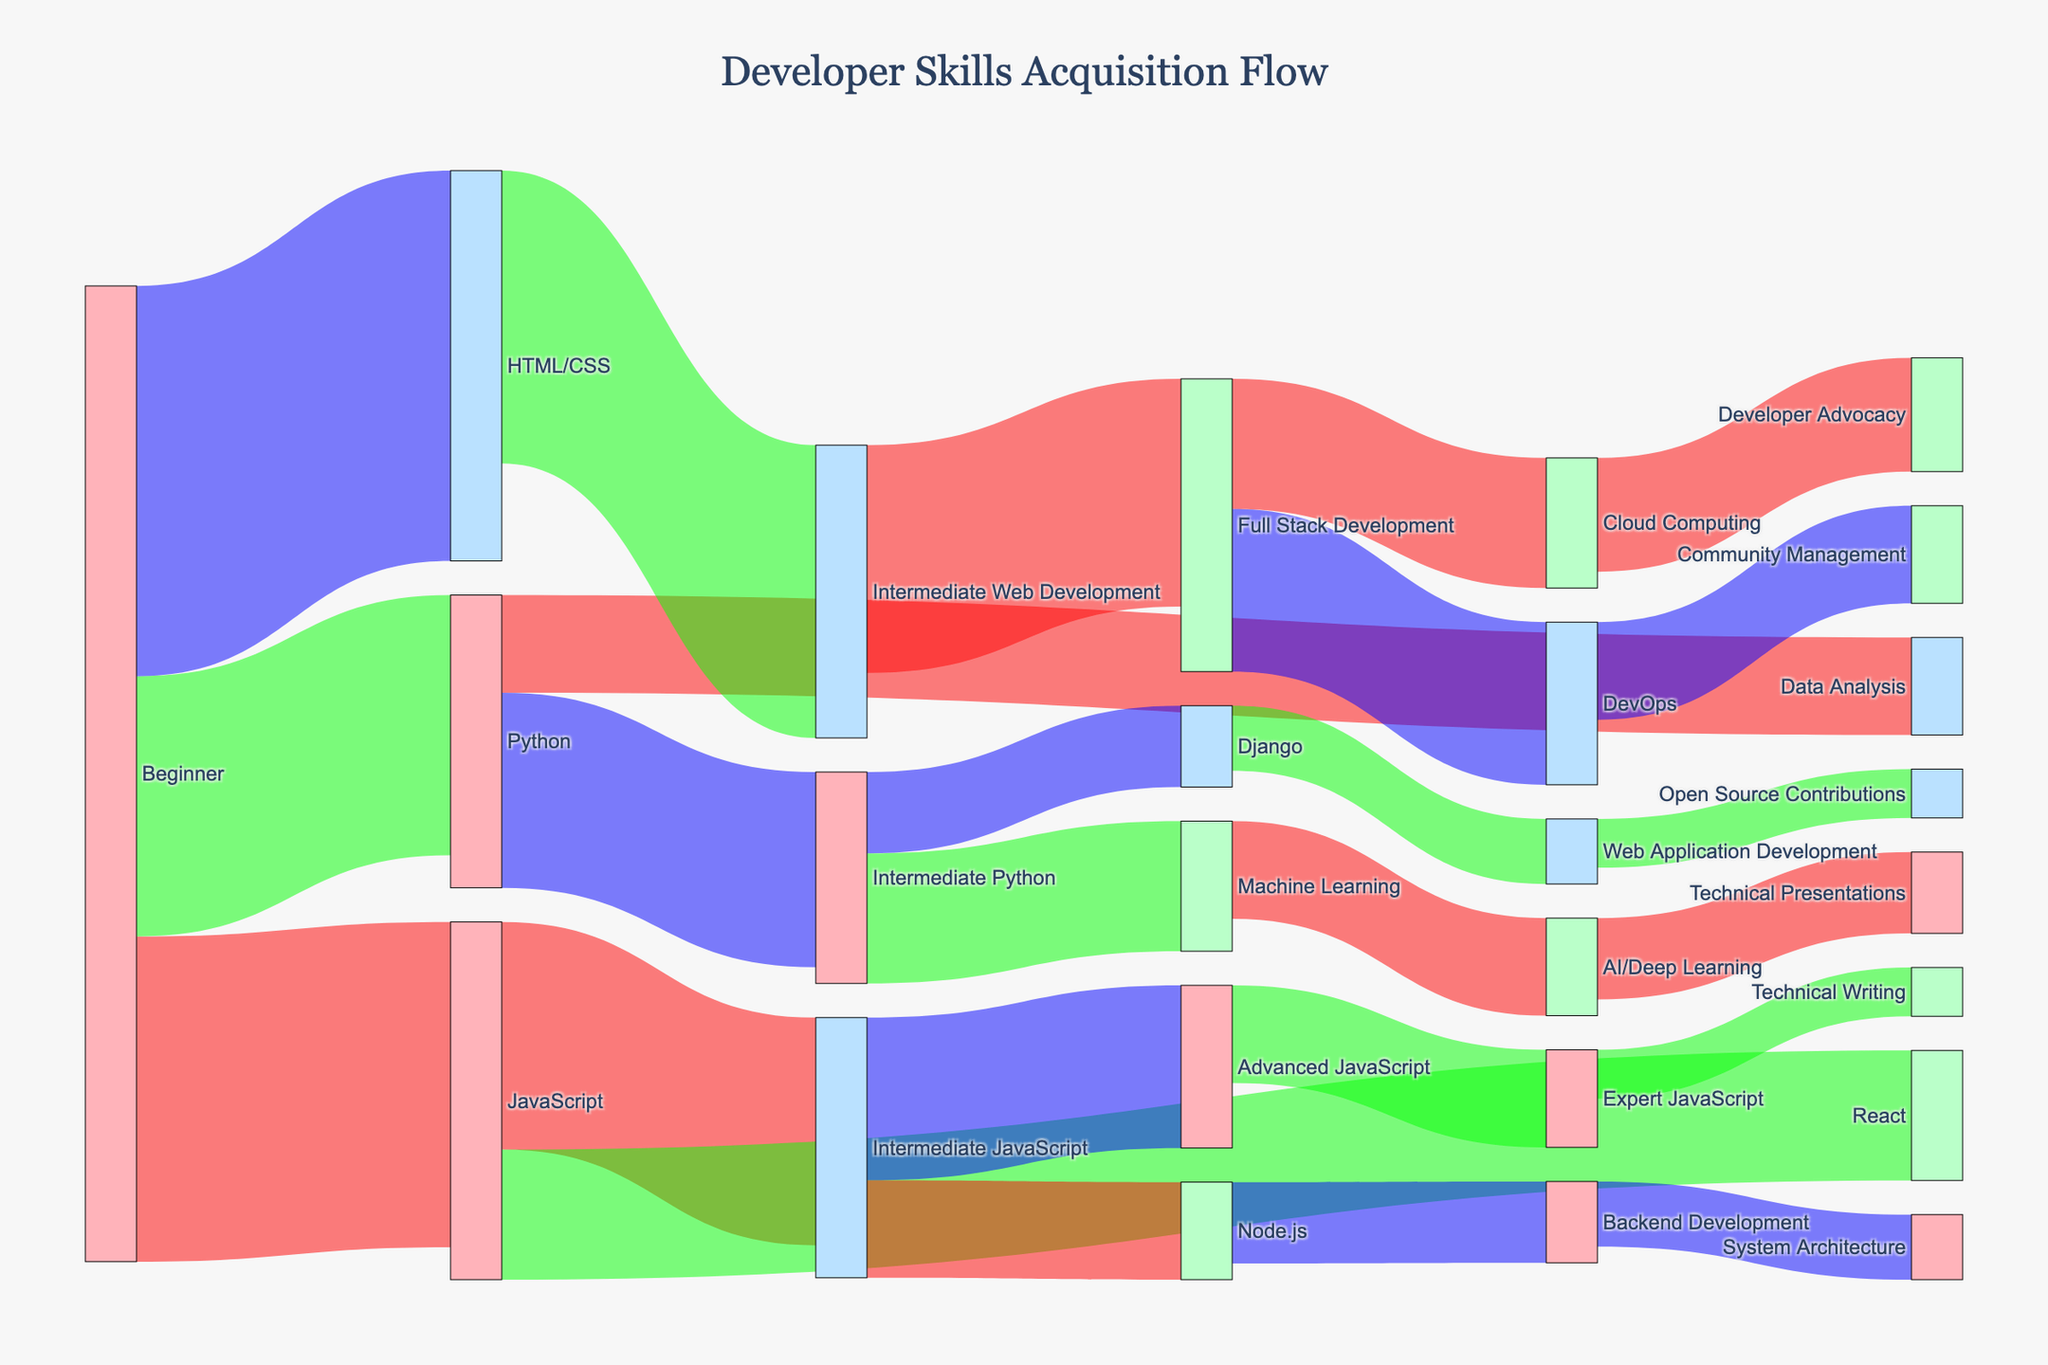What is the title of the diagram? The title is located at the top of the diagram. It provides context for what the diagram is about, making it easier to understand the information presented.
Answer: Developer Skills Acquisition Flow Which programming language do most beginners start with? Look at the nodes labeled 'Beginner' and trace the links to the programming languages. The one with the highest value will indicate the most common starting language.
Answer: HTML/CSS How many people move from Intermediate JavaScript to Advanced JavaScript? Identify the 'Intermediate JavaScript' node and find the link that connects to 'Advanced JavaScript'. The value on this link shows the number of people making this transition.
Answer: 50 What is the total number of developers that transition from Intermediate Python to other skills? From the 'Intermediate Python' node, locate all the outgoing links and sum their values. These values represent the number of developers moving to other skills.
Answer: 65 Compare the number of developers who transition to React versus those who transition to Data Analysis from the beginner level. From the beginner node, compare the values of the paths leading to 'React' and 'Data Analysis'. Look at their respective values.
Answer: React: 40, Data Analysis: 30 Which advanced skill has the lowest number of developers reaching it? Nodes representing advanced skills are connected by fewer intermediate paths. Find the node with the lowest value in its incoming links.
Answer: Technical Writing or Open Source Contributions (both 15) How many developers move from Full Stack Development to Cloud Computing? Trace the 'Full Stack Development' node and find its link to 'Cloud Computing'. The number on the link gives the required value.
Answer: 40 What intermediate skill in web development do most developers acquire? Focus on the 'HTML/CSS' node, find the link with the highest value leading to an intermediate web development skill.
Answer: Intermediate Web Development What is the combined number of developers who transition to AI/Deep Learning and System Architecture from their respective fields? Add the values of the links leading to 'AI/Deep Learning' and 'System Architecture' from their sources.
Answer: 30 (AI/Deep Learning) + 20 (System Architecture) = 50 In the transition from Intermediate Web Development, which advanced skill attracts more developers, DevOps or Cloud Computing? From 'Intermediate Web Development', compare the values of the transitions to 'DevOps' and 'Cloud Computing'. The one with the higher value attracts more developers.
Answer: DevOps 